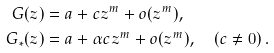Convert formula to latex. <formula><loc_0><loc_0><loc_500><loc_500>G ( z ) & = a + c z ^ { m } + o ( z ^ { m } ) , \\ G _ { * } ( z ) & = a + \alpha c z ^ { m } + o ( z ^ { m } ) , \quad \left ( c \ne 0 \right ) .</formula> 